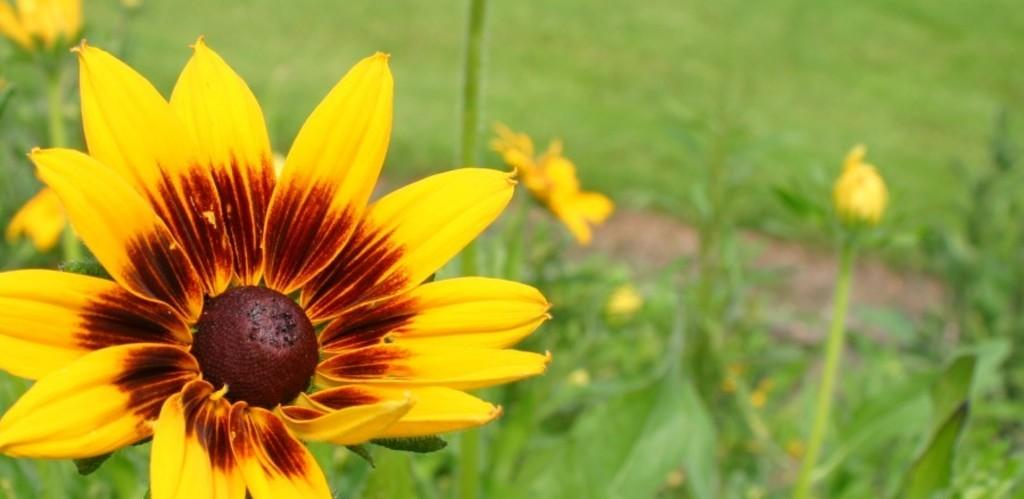What type of plants can be seen in the image? There are plants with flowers in the image. Can you describe the location of the flower in the image? There is a flower on the left side of the image. What type of landscape is visible at the top of the image? There is a grassland visible at the top of the image. What day of the week is depicted in the image? The image does not depict a specific day of the week; it only shows plants with flowers, a flower on the left side, and a grassland at the top. 